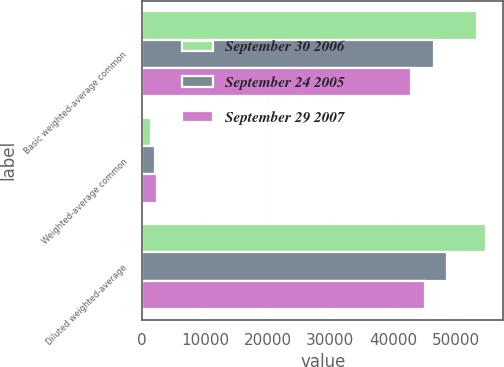Convert chart to OTSL. <chart><loc_0><loc_0><loc_500><loc_500><stacked_bar_chart><ecel><fcel>Basic weighted-average common<fcel>Weighted-average common<fcel>Diluted weighted-average<nl><fcel>September 30 2006<fcel>53436<fcel>1398<fcel>54834<nl><fcel>September 24 2005<fcel>46512<fcel>2108<fcel>48620<nl><fcel>September 29 2007<fcel>42824<fcel>2302<fcel>45126<nl></chart> 